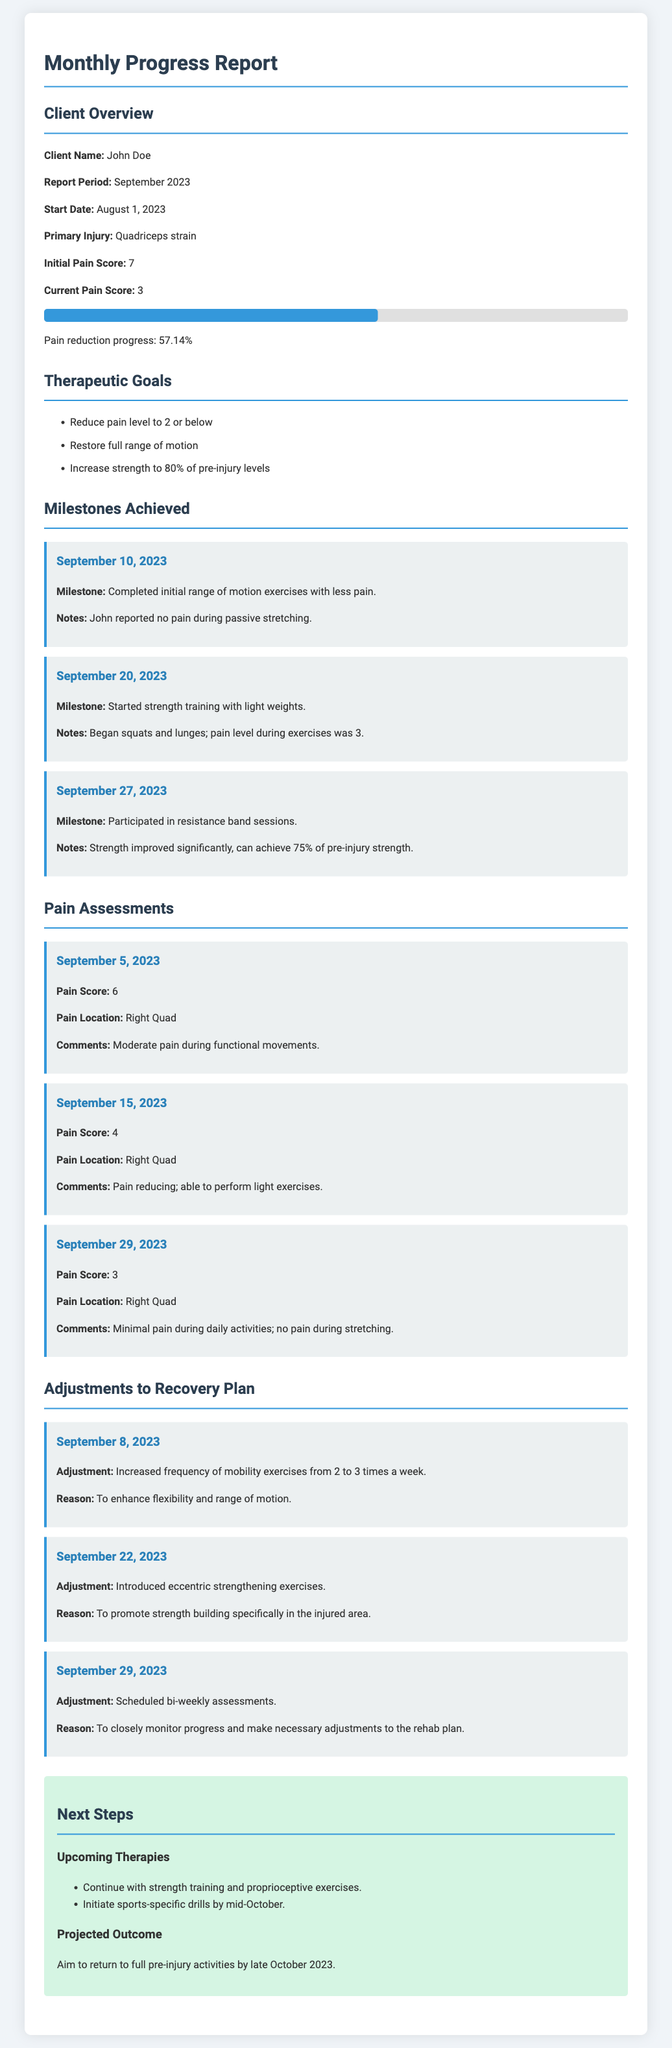What is the primary injury? The primary injury is specified in the document, which states it is a quadriceps strain.
Answer: Quadriceps strain What was the initial pain score? The document provides the initial pain score of the client at the beginning of the report, which is indicated as 7.
Answer: 7 What date did John complete the initial range of motion exercises? The specific date for the completion of initial range of motion exercises is provided as September 10, 2023.
Answer: September 10, 2023 What is the current pain score? The document indicates the current pain score of the client, which is stated as 3.
Answer: 3 What adjustment was made on September 22, 2023? The document specifies the adjustment made on this date as the introduction of eccentric strengthening exercises.
Answer: Introduced eccentric strengthening exercises What is the aim for projected outcome in the rehabilitation journey? The document describes the projected outcome as aiming to return to full pre-injury activities by late October 2023.
Answer: Late October 2023 How much has pain reduced in percentage? The document mentions the pain reduction progress which is calculated as 57.14%.
Answer: 57.14% On what date did John start strength training with light weights? The date provided in the document for when John started strength training is September 20, 2023.
Answer: September 20, 2023 What kind of exercises will John continue with in the next steps? The document indicates that John will continue with strength training and proprioceptive exercises.
Answer: Strength training and proprioceptive exercises 